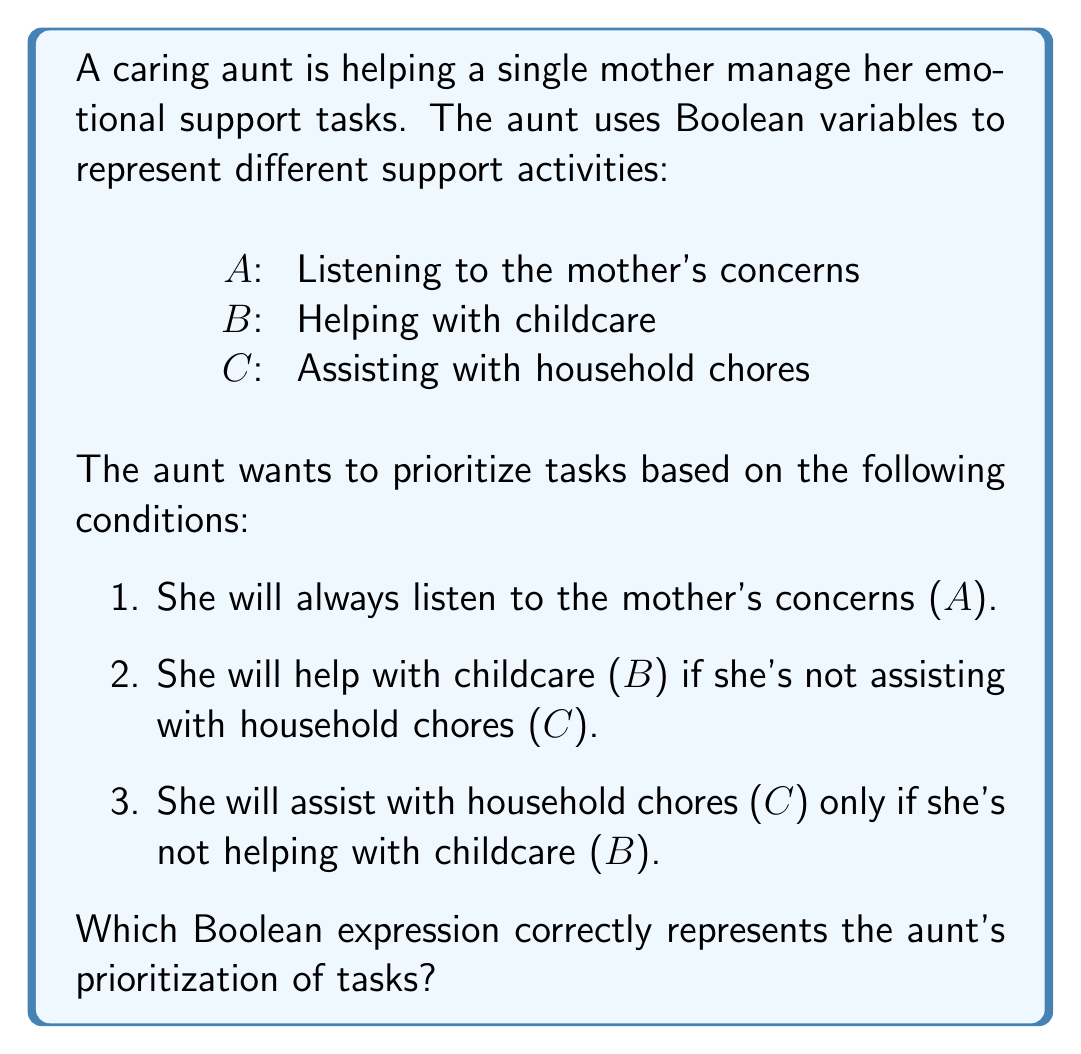Can you answer this question? Let's break down the conditions and translate them into Boolean expressions:

1. The aunt will always listen to the mother's concerns: This means $A$ is always true, so we start with $A$.

2. She will help with childcare ($B$) if she's not assisting with household chores ($C$): This can be expressed as $\overline{C} \rightarrow B$, which is equivalent to $C + B$.

3. She will assist with household chores ($C$) only if she's not helping with childcare ($B$): This can be expressed as $C \rightarrow \overline{B}$, which is equivalent to $\overline{C} + \overline{B}$.

Now, we need to combine these conditions using the AND operator ($\cdot$):

$$ A \cdot (C + B) \cdot (\overline{C} + \overline{B}) $$

Simplifying this expression:

$$ A \cdot (C + B) \cdot (\overline{C} + \overline{B}) $$
$$ = A \cdot [(C \cdot \overline{C}) + (C \cdot \overline{B}) + (B \cdot \overline{C}) + (B \cdot \overline{B})] $$
$$ = A \cdot [(0) + (C \cdot \overline{B}) + (B \cdot \overline{C}) + (0)] $$
$$ = A \cdot (C \cdot \overline{B} + B \cdot \overline{C}) $$

This final expression represents the aunt's prioritization of tasks, ensuring she always listens to concerns ($A$) and either helps with childcare ($B$) or household chores ($C$), but not both simultaneously.
Answer: $A \cdot (C \cdot \overline{B} + B \cdot \overline{C})$ 